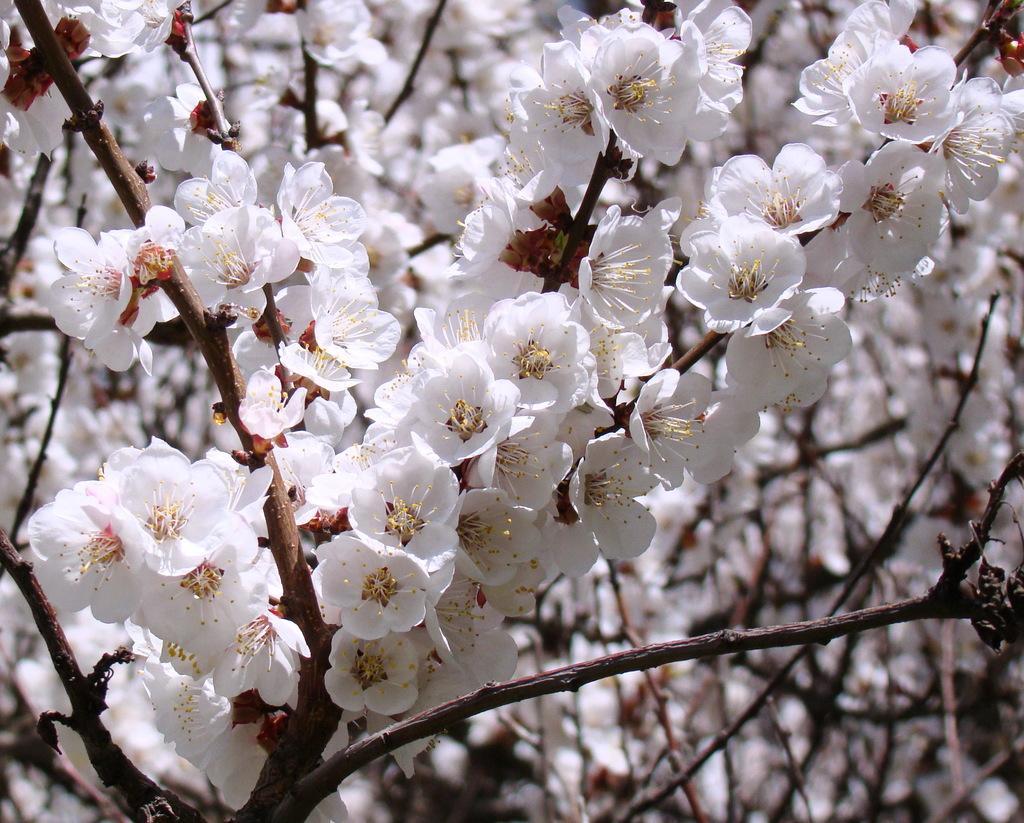Can you describe this image briefly? In this image we can see blossoms. 